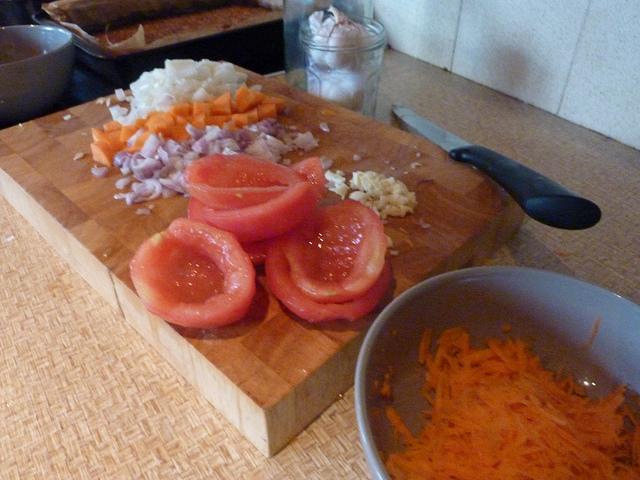Are carrots healthy?
Keep it brief. Yes. Is that a carving knife?
Be succinct. Yes. What's for lunch?
Answer briefly. Stuffed tomatoes. What has been scooped out from the tomatoes?
Give a very brief answer. Seeds. 